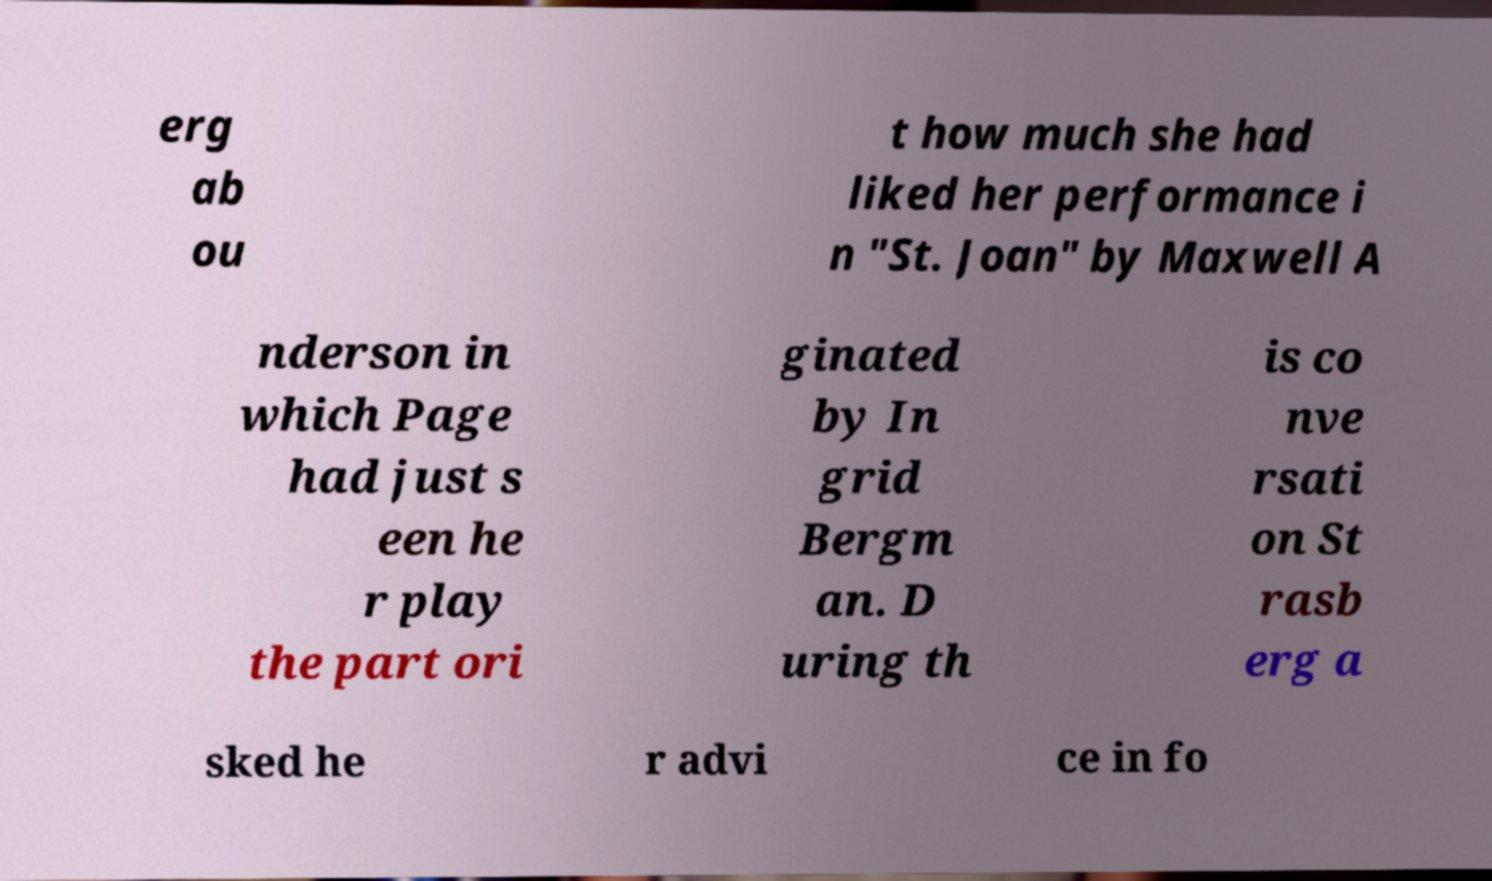For documentation purposes, I need the text within this image transcribed. Could you provide that? erg ab ou t how much she had liked her performance i n "St. Joan" by Maxwell A nderson in which Page had just s een he r play the part ori ginated by In grid Bergm an. D uring th is co nve rsati on St rasb erg a sked he r advi ce in fo 